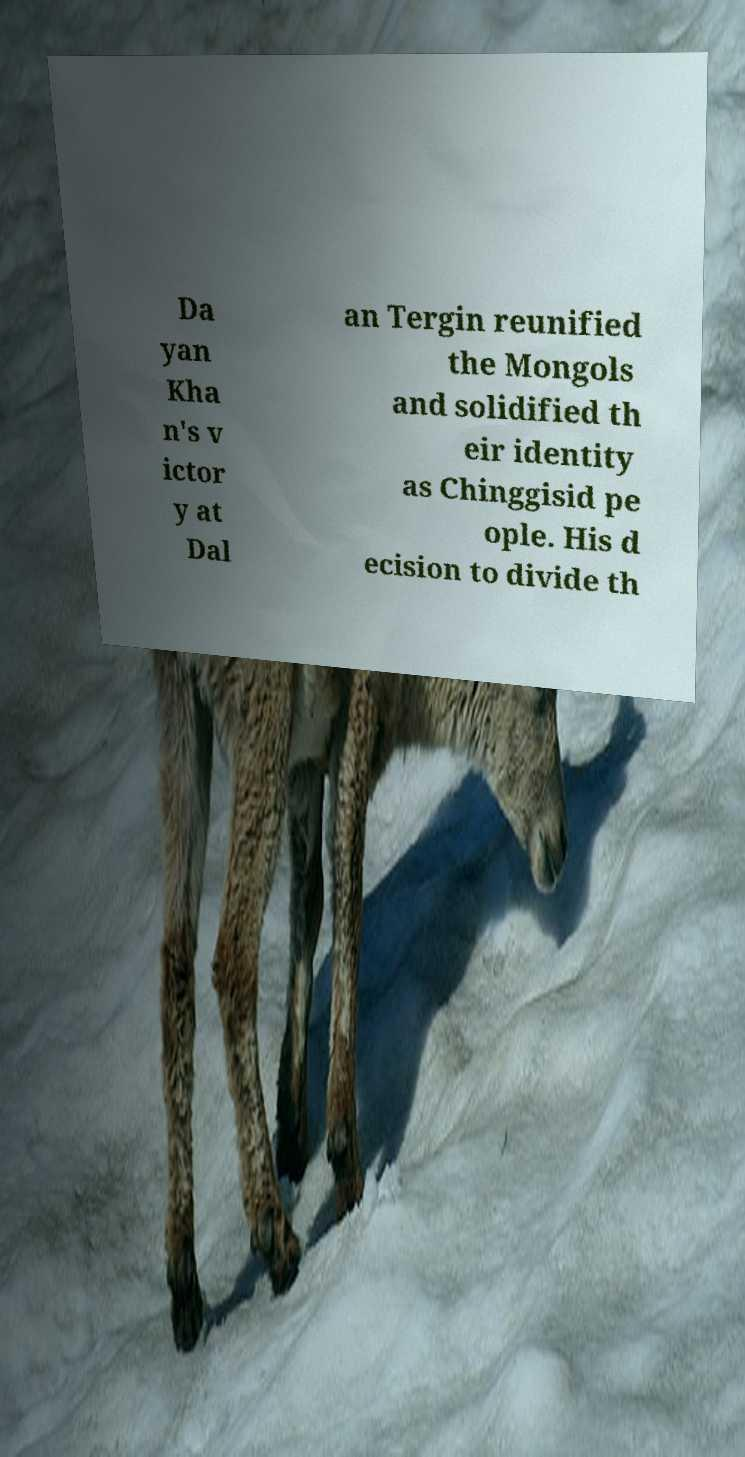Can you accurately transcribe the text from the provided image for me? Da yan Kha n's v ictor y at Dal an Tergin reunified the Mongols and solidified th eir identity as Chinggisid pe ople. His d ecision to divide th 